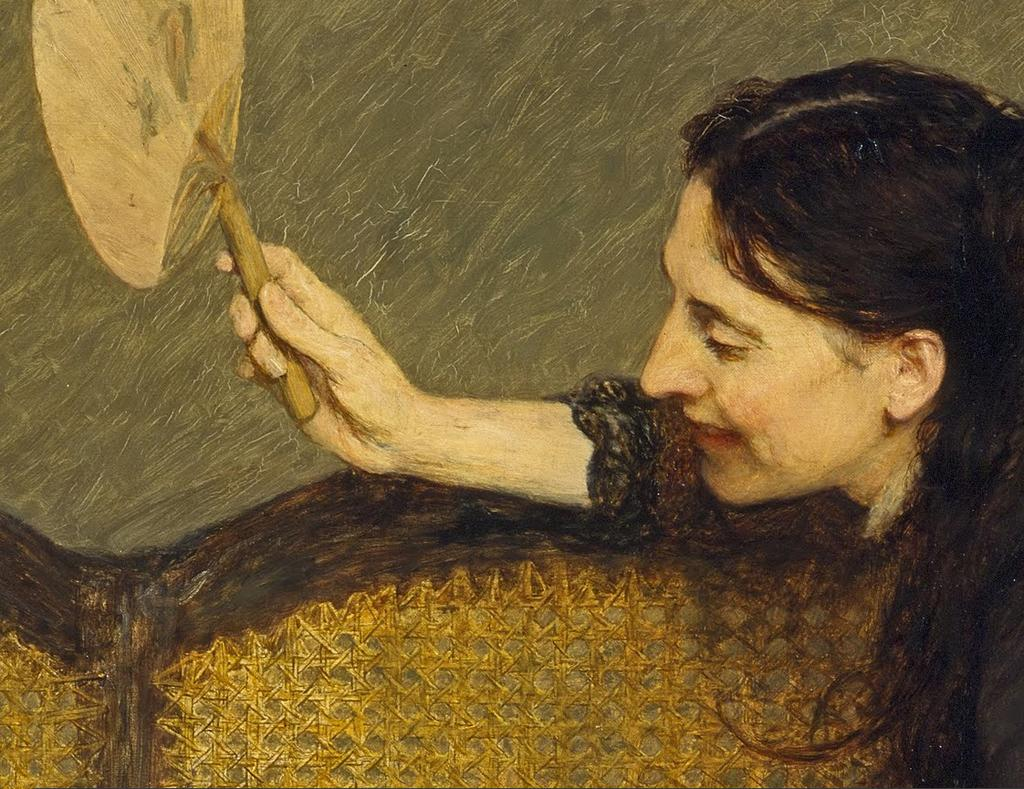What is depicted in the painting in the image? There is a painting of a person in the image. What is the person in the painting holding? The person in the painting is holding an object. What type of furniture is present in the image? There is a bench in the image. What is the color of the bench? The bench is brown in color. What time of day does the painting depict in the image? The provided facts do not mention the time of day depicted in the painting, so it cannot be determined from the image. 